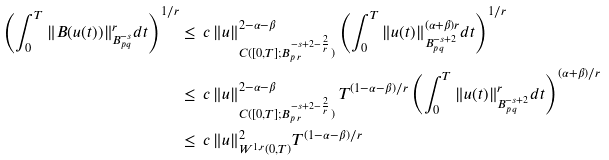<formula> <loc_0><loc_0><loc_500><loc_500>\left ( \int _ { 0 } ^ { T } \| B ( u ( t ) ) \| ^ { r } _ { B ^ { - s } _ { p \, q } } d t \right ) ^ { 1 / r } & \leq \, c \, \| u \| ^ { 2 - \alpha - \beta } _ { C ( [ 0 , T ] ; B ^ { - s + 2 - \frac { 2 } { r } } _ { p \, r } ) } \left ( \int _ { 0 } ^ { T } \| u ( t ) \| ^ { ( \alpha + \beta ) r } _ { B ^ { - s + 2 } _ { p \, q } } d t \right ) ^ { 1 / r } \\ & \leq \, c \, \| u \| ^ { 2 - \alpha - \beta } _ { C ( [ 0 , T ] ; B ^ { - s + 2 - \frac { 2 } { r } } _ { p \, r } ) } \, T ^ { ( 1 - \alpha - \beta ) / r } \left ( \int _ { 0 } ^ { T } \| u ( t ) \| ^ { r } _ { B ^ { - s + 2 } _ { p \, q } } d t \right ) ^ { ( \alpha + \beta ) / r } \\ & \leq \, c \, \| u \| ^ { 2 } _ { W ^ { 1 , r } ( 0 , T ) } T ^ { ( 1 - \alpha - \beta ) / r } \\</formula> 